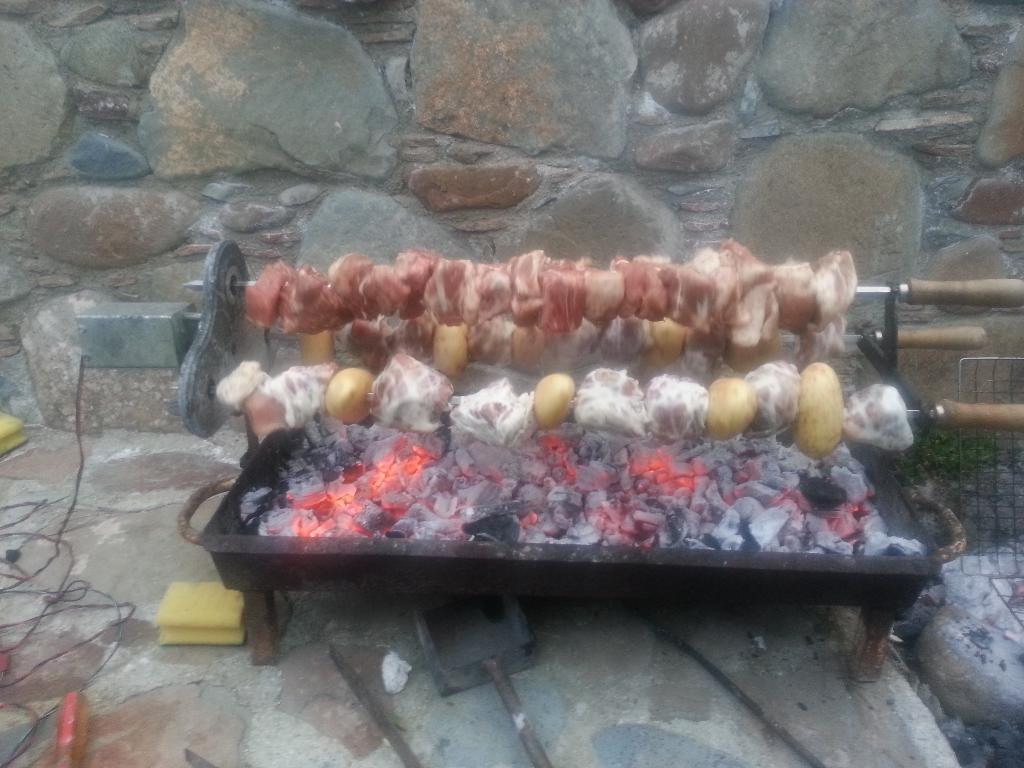Could you give a brief overview of what you see in this image? Here I can see a metal object which consists of fire coals. It is placed on the floor. On this there are barbecues. On the left side few cables are placed on the ground. At the bottom there are few tools. In the background there is a wall. On the right side there is a metal frame. 